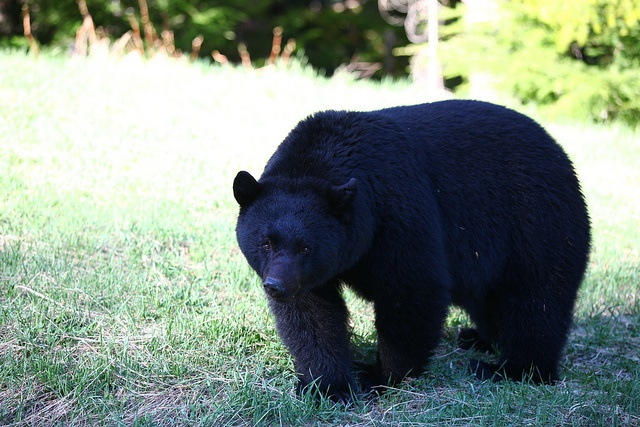Describe the objects in this image and their specific colors. I can see a bear in black, navy, blue, and gray tones in this image. 